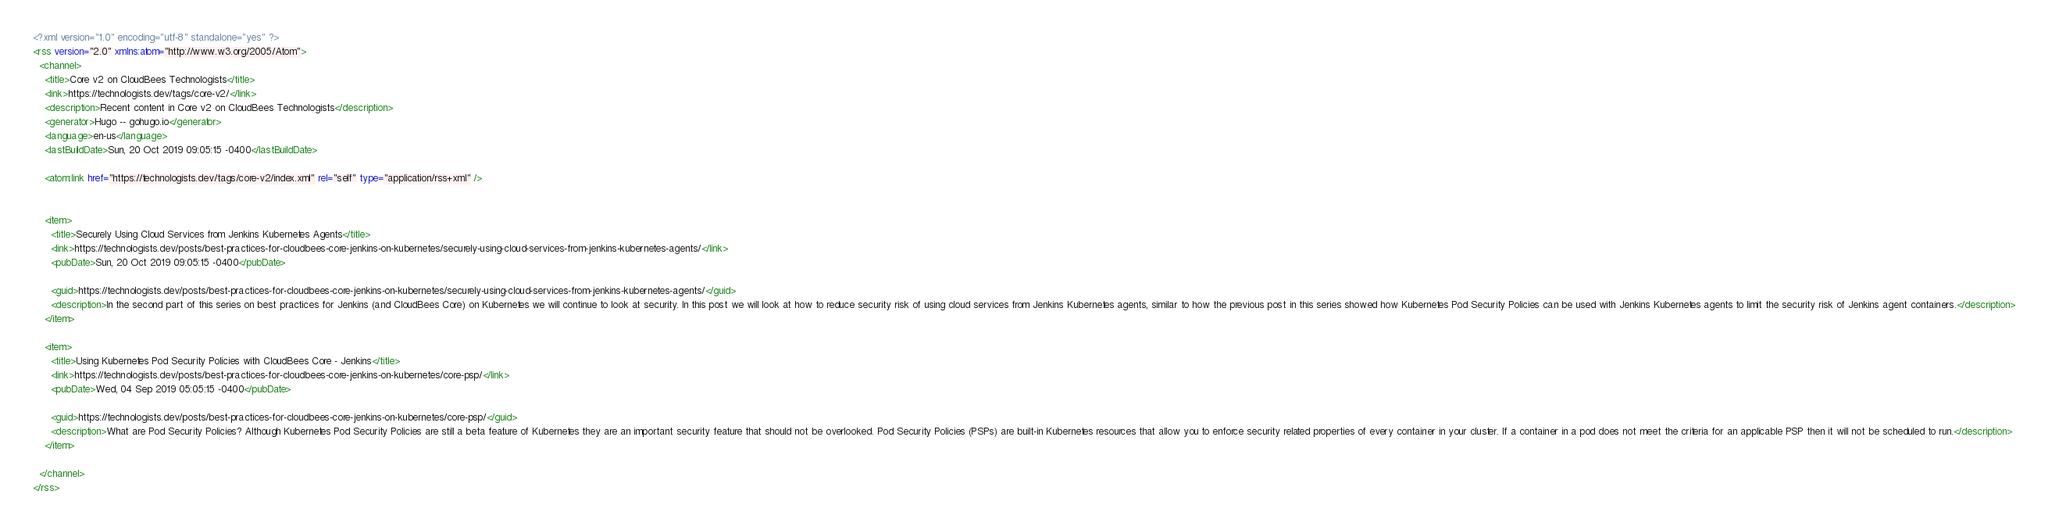<code> <loc_0><loc_0><loc_500><loc_500><_XML_><?xml version="1.0" encoding="utf-8" standalone="yes" ?>
<rss version="2.0" xmlns:atom="http://www.w3.org/2005/Atom">
  <channel>
    <title>Core v2 on CloudBees Technologists</title>
    <link>https://technologists.dev/tags/core-v2/</link>
    <description>Recent content in Core v2 on CloudBees Technologists</description>
    <generator>Hugo -- gohugo.io</generator>
    <language>en-us</language>
    <lastBuildDate>Sun, 20 Oct 2019 09:05:15 -0400</lastBuildDate>
    
	<atom:link href="https://technologists.dev/tags/core-v2/index.xml" rel="self" type="application/rss+xml" />
    
    
    <item>
      <title>Securely Using Cloud Services from Jenkins Kubernetes Agents</title>
      <link>https://technologists.dev/posts/best-practices-for-cloudbees-core-jenkins-on-kubernetes/securely-using-cloud-services-from-jenkins-kubernetes-agents/</link>
      <pubDate>Sun, 20 Oct 2019 09:05:15 -0400</pubDate>
      
      <guid>https://technologists.dev/posts/best-practices-for-cloudbees-core-jenkins-on-kubernetes/securely-using-cloud-services-from-jenkins-kubernetes-agents/</guid>
      <description>In the second part of this series on best practices for Jenkins (and CloudBees Core) on Kubernetes we will continue to look at security. In this post we will look at how to reduce security risk of using cloud services from Jenkins Kubernetes agents, similar to how the previous post in this series showed how Kubernetes Pod Security Policies can be used with Jenkins Kubernetes agents to limit the security risk of Jenkins agent containers.</description>
    </item>
    
    <item>
      <title>Using Kubernetes Pod Security Policies with CloudBees Core - Jenkins</title>
      <link>https://technologists.dev/posts/best-practices-for-cloudbees-core-jenkins-on-kubernetes/core-psp/</link>
      <pubDate>Wed, 04 Sep 2019 05:05:15 -0400</pubDate>
      
      <guid>https://technologists.dev/posts/best-practices-for-cloudbees-core-jenkins-on-kubernetes/core-psp/</guid>
      <description>What are Pod Security Policies? Although Kubernetes Pod Security Policies are still a beta feature of Kubernetes they are an important security feature that should not be overlooked. Pod Security Policies (PSPs) are built-in Kubernetes resources that allow you to enforce security related properties of every container in your cluster. If a container in a pod does not meet the criteria for an applicable PSP then it will not be scheduled to run.</description>
    </item>
    
  </channel>
</rss></code> 